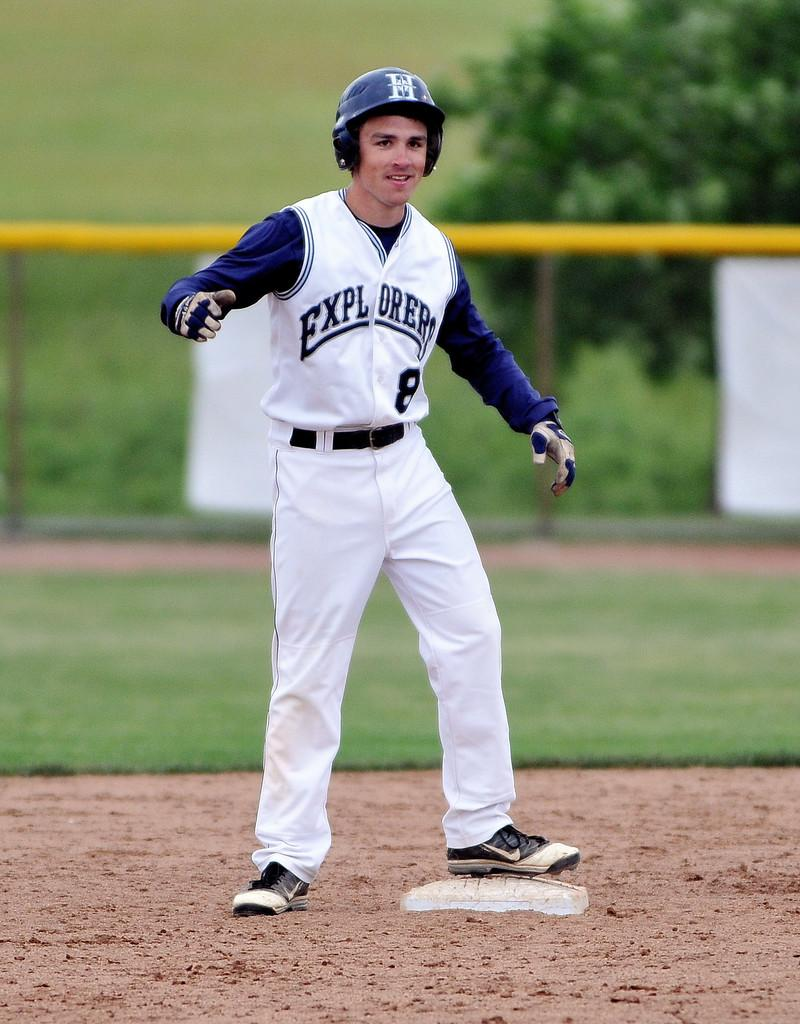Provide a one-sentence caption for the provided image. A young man in a Explorers baseball uniform in blue and white standing on a base on a baseball field. 